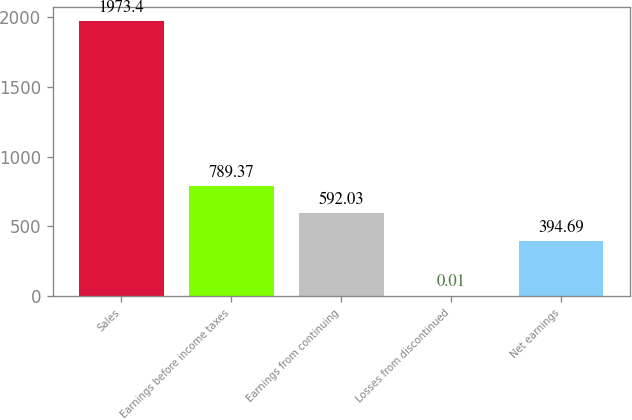Convert chart to OTSL. <chart><loc_0><loc_0><loc_500><loc_500><bar_chart><fcel>Sales<fcel>Earnings before income taxes<fcel>Earnings from continuing<fcel>Losses from discontinued<fcel>Net earnings<nl><fcel>1973.4<fcel>789.37<fcel>592.03<fcel>0.01<fcel>394.69<nl></chart> 